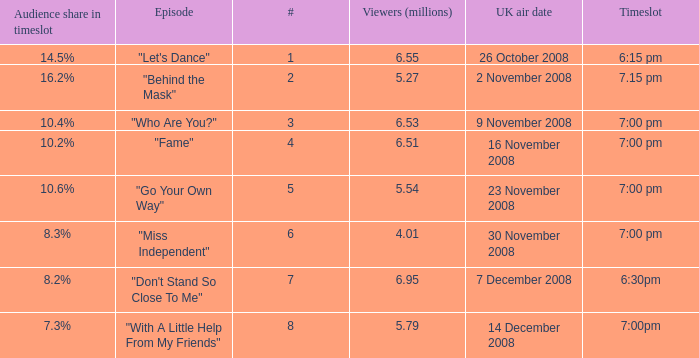Name the total number of viewers for audience share in timeslot for 10.2% 1.0. 